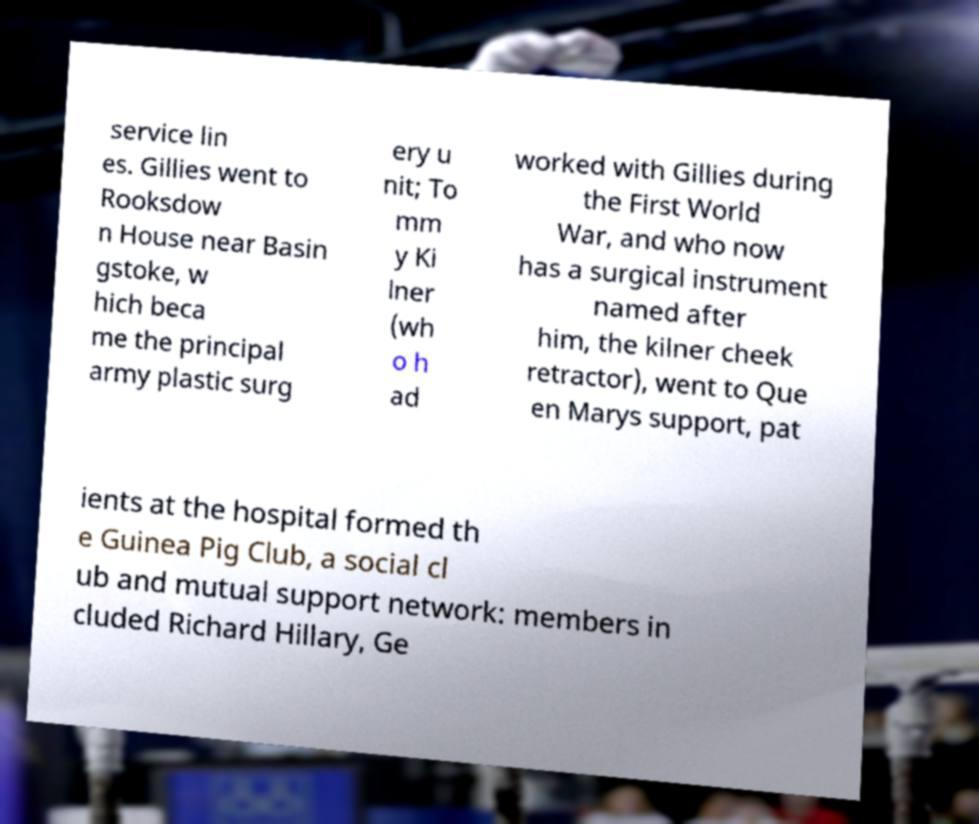Please identify and transcribe the text found in this image. service lin es. Gillies went to Rooksdow n House near Basin gstoke, w hich beca me the principal army plastic surg ery u nit; To mm y Ki lner (wh o h ad worked with Gillies during the First World War, and who now has a surgical instrument named after him, the kilner cheek retractor), went to Que en Marys support, pat ients at the hospital formed th e Guinea Pig Club, a social cl ub and mutual support network: members in cluded Richard Hillary, Ge 